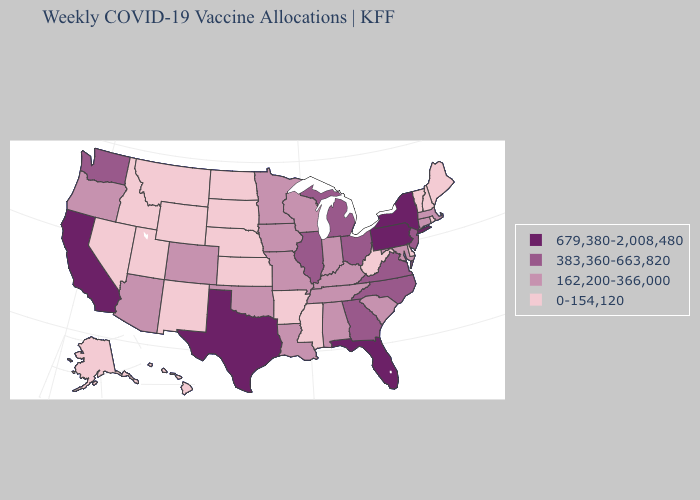Among the states that border Mississippi , does Louisiana have the highest value?
Be succinct. Yes. Name the states that have a value in the range 679,380-2,008,480?
Quick response, please. California, Florida, New York, Pennsylvania, Texas. Does the first symbol in the legend represent the smallest category?
Give a very brief answer. No. Which states have the highest value in the USA?
Be succinct. California, Florida, New York, Pennsylvania, Texas. What is the value of Delaware?
Quick response, please. 0-154,120. Name the states that have a value in the range 162,200-366,000?
Be succinct. Alabama, Arizona, Colorado, Connecticut, Indiana, Iowa, Kentucky, Louisiana, Maryland, Massachusetts, Minnesota, Missouri, Oklahoma, Oregon, South Carolina, Tennessee, Wisconsin. Among the states that border Illinois , which have the highest value?
Be succinct. Indiana, Iowa, Kentucky, Missouri, Wisconsin. What is the lowest value in the South?
Answer briefly. 0-154,120. Among the states that border Ohio , which have the lowest value?
Be succinct. West Virginia. Is the legend a continuous bar?
Keep it brief. No. What is the lowest value in the Northeast?
Quick response, please. 0-154,120. What is the highest value in the USA?
Be succinct. 679,380-2,008,480. What is the value of Nebraska?
Quick response, please. 0-154,120. Name the states that have a value in the range 0-154,120?
Give a very brief answer. Alaska, Arkansas, Delaware, Hawaii, Idaho, Kansas, Maine, Mississippi, Montana, Nebraska, Nevada, New Hampshire, New Mexico, North Dakota, Rhode Island, South Dakota, Utah, Vermont, West Virginia, Wyoming. Which states have the highest value in the USA?
Answer briefly. California, Florida, New York, Pennsylvania, Texas. 